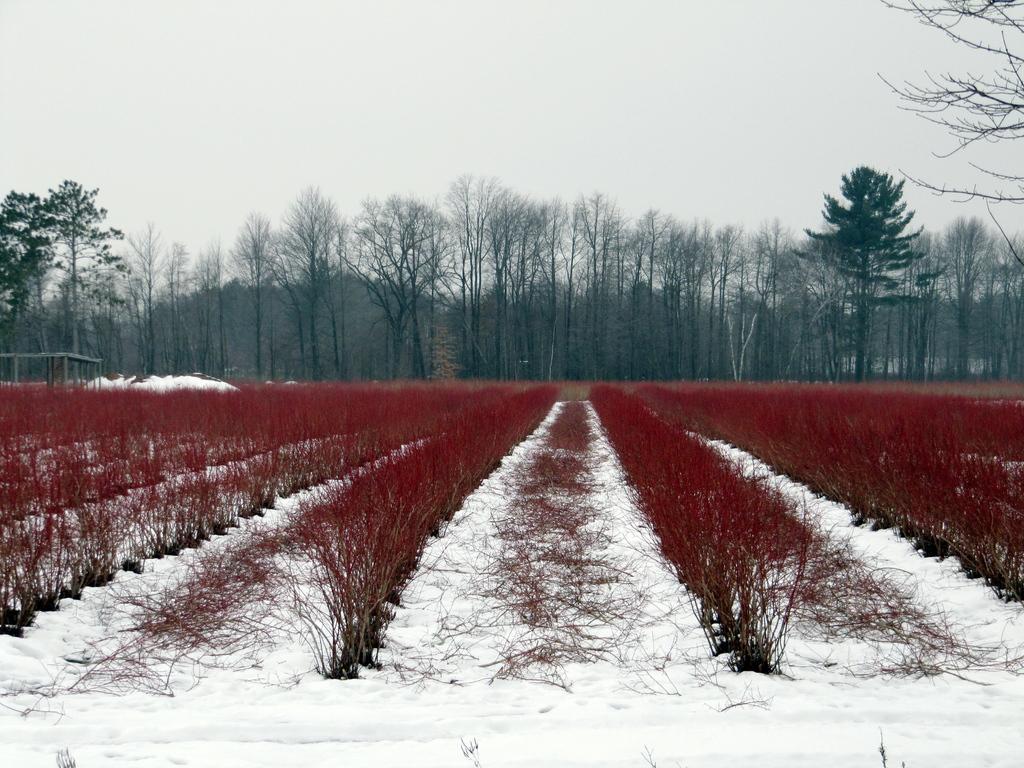Can you describe this image briefly? In this image we can see snow and some red color pants and in the background of the image there are some trees and clear sky. 